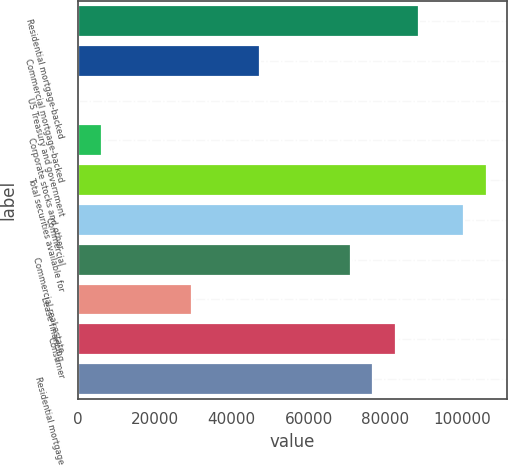<chart> <loc_0><loc_0><loc_500><loc_500><bar_chart><fcel>Residential mortgage-backed<fcel>Commercial mortgage-backed<fcel>US Treasury and government<fcel>Corporate stocks and other<fcel>Total securities available for<fcel>Commercial<fcel>Commercial real estate<fcel>Lease financing<fcel>Consumer<fcel>Residential mortgage<nl><fcel>88680.5<fcel>47433<fcel>293<fcel>6185.5<fcel>106358<fcel>100466<fcel>71003<fcel>29755.5<fcel>82788<fcel>76895.5<nl></chart> 